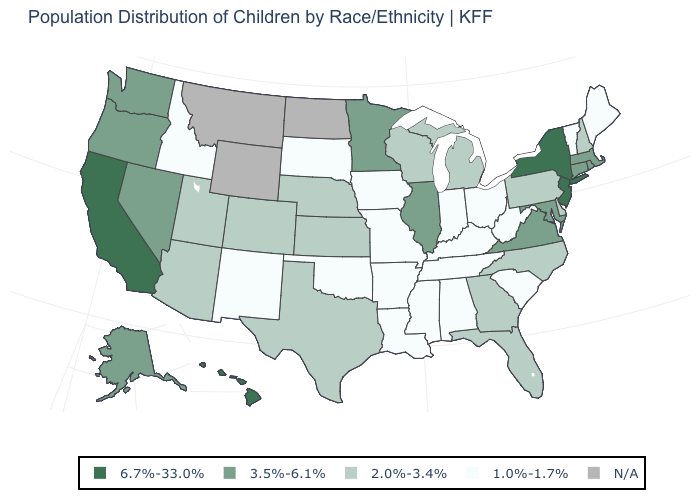What is the value of Maine?
Answer briefly. 1.0%-1.7%. What is the lowest value in the USA?
Keep it brief. 1.0%-1.7%. What is the value of South Carolina?
Keep it brief. 1.0%-1.7%. What is the highest value in the Northeast ?
Keep it brief. 6.7%-33.0%. Among the states that border New Mexico , which have the lowest value?
Quick response, please. Oklahoma. What is the value of North Carolina?
Concise answer only. 2.0%-3.4%. What is the value of Massachusetts?
Answer briefly. 3.5%-6.1%. What is the value of Georgia?
Quick response, please. 2.0%-3.4%. What is the value of Colorado?
Write a very short answer. 2.0%-3.4%. What is the lowest value in states that border Rhode Island?
Quick response, please. 3.5%-6.1%. Name the states that have a value in the range N/A?
Short answer required. Montana, North Dakota, Wyoming. Is the legend a continuous bar?
Give a very brief answer. No. What is the value of New Jersey?
Answer briefly. 6.7%-33.0%. What is the value of California?
Be succinct. 6.7%-33.0%. 